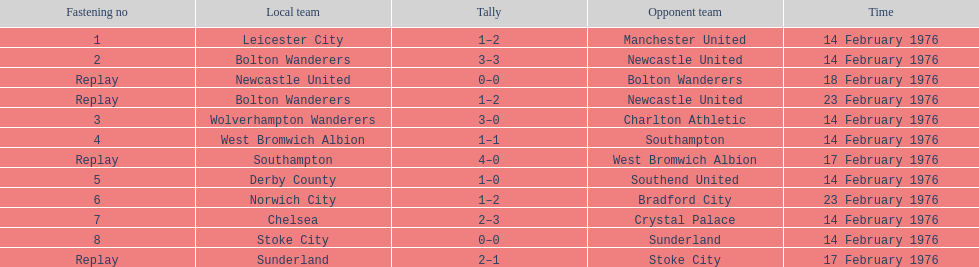What is the difference between southampton's score and sunderland's score? 2 goals. 